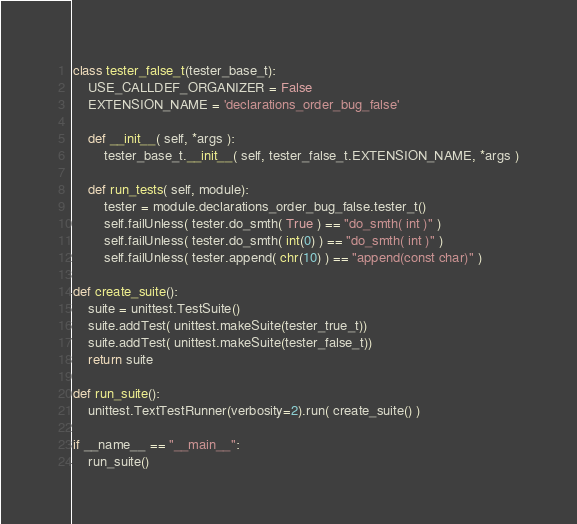Convert code to text. <code><loc_0><loc_0><loc_500><loc_500><_Python_>
class tester_false_t(tester_base_t):
    USE_CALLDEF_ORGANIZER = False
    EXTENSION_NAME = 'declarations_order_bug_false'

    def __init__( self, *args ):
        tester_base_t.__init__( self, tester_false_t.EXTENSION_NAME, *args )

    def run_tests( self, module):
        tester = module.declarations_order_bug_false.tester_t()
        self.failUnless( tester.do_smth( True ) == "do_smth( int )" )
        self.failUnless( tester.do_smth( int(0) ) == "do_smth( int )" )
        self.failUnless( tester.append( chr(10) ) == "append(const char)" )

def create_suite():
    suite = unittest.TestSuite()    
    suite.addTest( unittest.makeSuite(tester_true_t))
    suite.addTest( unittest.makeSuite(tester_false_t))
    return suite

def run_suite():
    unittest.TextTestRunner(verbosity=2).run( create_suite() )

if __name__ == "__main__":
    run_suite()
</code> 